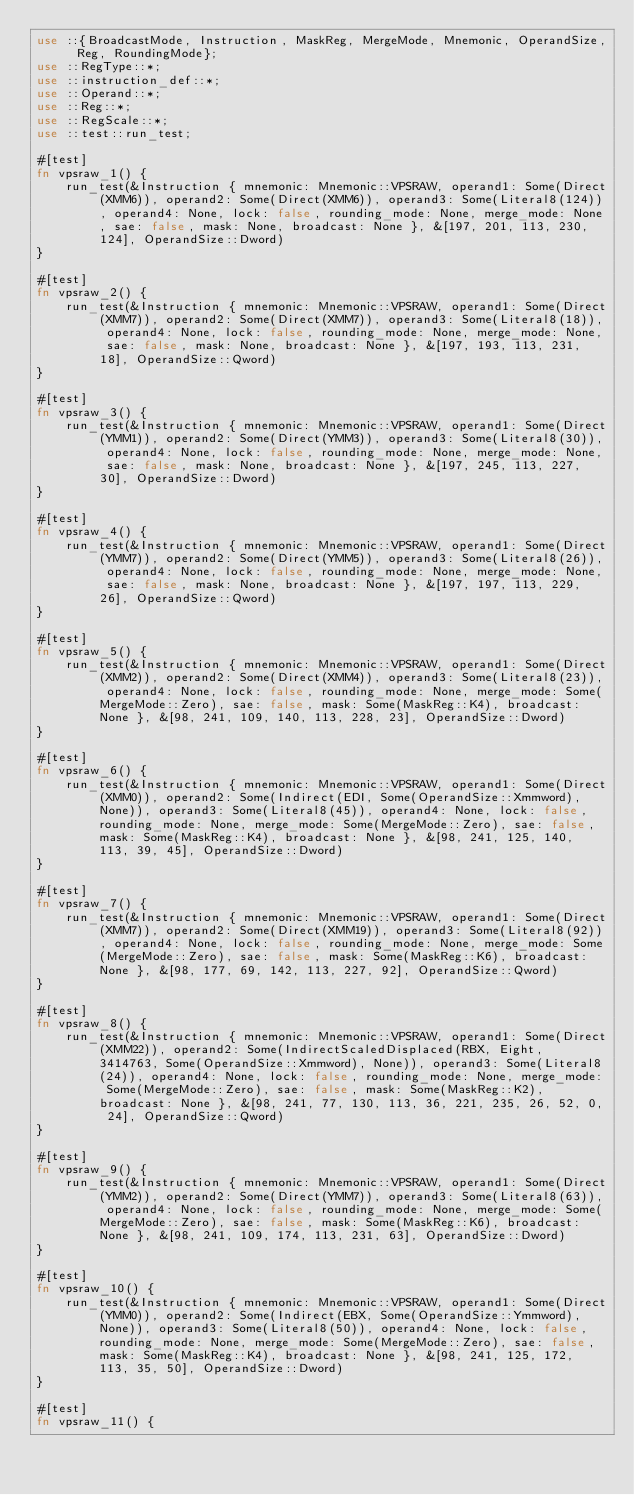<code> <loc_0><loc_0><loc_500><loc_500><_Rust_>use ::{BroadcastMode, Instruction, MaskReg, MergeMode, Mnemonic, OperandSize, Reg, RoundingMode};
use ::RegType::*;
use ::instruction_def::*;
use ::Operand::*;
use ::Reg::*;
use ::RegScale::*;
use ::test::run_test;

#[test]
fn vpsraw_1() {
    run_test(&Instruction { mnemonic: Mnemonic::VPSRAW, operand1: Some(Direct(XMM6)), operand2: Some(Direct(XMM6)), operand3: Some(Literal8(124)), operand4: None, lock: false, rounding_mode: None, merge_mode: None, sae: false, mask: None, broadcast: None }, &[197, 201, 113, 230, 124], OperandSize::Dword)
}

#[test]
fn vpsraw_2() {
    run_test(&Instruction { mnemonic: Mnemonic::VPSRAW, operand1: Some(Direct(XMM7)), operand2: Some(Direct(XMM7)), operand3: Some(Literal8(18)), operand4: None, lock: false, rounding_mode: None, merge_mode: None, sae: false, mask: None, broadcast: None }, &[197, 193, 113, 231, 18], OperandSize::Qword)
}

#[test]
fn vpsraw_3() {
    run_test(&Instruction { mnemonic: Mnemonic::VPSRAW, operand1: Some(Direct(YMM1)), operand2: Some(Direct(YMM3)), operand3: Some(Literal8(30)), operand4: None, lock: false, rounding_mode: None, merge_mode: None, sae: false, mask: None, broadcast: None }, &[197, 245, 113, 227, 30], OperandSize::Dword)
}

#[test]
fn vpsraw_4() {
    run_test(&Instruction { mnemonic: Mnemonic::VPSRAW, operand1: Some(Direct(YMM7)), operand2: Some(Direct(YMM5)), operand3: Some(Literal8(26)), operand4: None, lock: false, rounding_mode: None, merge_mode: None, sae: false, mask: None, broadcast: None }, &[197, 197, 113, 229, 26], OperandSize::Qword)
}

#[test]
fn vpsraw_5() {
    run_test(&Instruction { mnemonic: Mnemonic::VPSRAW, operand1: Some(Direct(XMM2)), operand2: Some(Direct(XMM4)), operand3: Some(Literal8(23)), operand4: None, lock: false, rounding_mode: None, merge_mode: Some(MergeMode::Zero), sae: false, mask: Some(MaskReg::K4), broadcast: None }, &[98, 241, 109, 140, 113, 228, 23], OperandSize::Dword)
}

#[test]
fn vpsraw_6() {
    run_test(&Instruction { mnemonic: Mnemonic::VPSRAW, operand1: Some(Direct(XMM0)), operand2: Some(Indirect(EDI, Some(OperandSize::Xmmword), None)), operand3: Some(Literal8(45)), operand4: None, lock: false, rounding_mode: None, merge_mode: Some(MergeMode::Zero), sae: false, mask: Some(MaskReg::K4), broadcast: None }, &[98, 241, 125, 140, 113, 39, 45], OperandSize::Dword)
}

#[test]
fn vpsraw_7() {
    run_test(&Instruction { mnemonic: Mnemonic::VPSRAW, operand1: Some(Direct(XMM7)), operand2: Some(Direct(XMM19)), operand3: Some(Literal8(92)), operand4: None, lock: false, rounding_mode: None, merge_mode: Some(MergeMode::Zero), sae: false, mask: Some(MaskReg::K6), broadcast: None }, &[98, 177, 69, 142, 113, 227, 92], OperandSize::Qword)
}

#[test]
fn vpsraw_8() {
    run_test(&Instruction { mnemonic: Mnemonic::VPSRAW, operand1: Some(Direct(XMM22)), operand2: Some(IndirectScaledDisplaced(RBX, Eight, 3414763, Some(OperandSize::Xmmword), None)), operand3: Some(Literal8(24)), operand4: None, lock: false, rounding_mode: None, merge_mode: Some(MergeMode::Zero), sae: false, mask: Some(MaskReg::K2), broadcast: None }, &[98, 241, 77, 130, 113, 36, 221, 235, 26, 52, 0, 24], OperandSize::Qword)
}

#[test]
fn vpsraw_9() {
    run_test(&Instruction { mnemonic: Mnemonic::VPSRAW, operand1: Some(Direct(YMM2)), operand2: Some(Direct(YMM7)), operand3: Some(Literal8(63)), operand4: None, lock: false, rounding_mode: None, merge_mode: Some(MergeMode::Zero), sae: false, mask: Some(MaskReg::K6), broadcast: None }, &[98, 241, 109, 174, 113, 231, 63], OperandSize::Dword)
}

#[test]
fn vpsraw_10() {
    run_test(&Instruction { mnemonic: Mnemonic::VPSRAW, operand1: Some(Direct(YMM0)), operand2: Some(Indirect(EBX, Some(OperandSize::Ymmword), None)), operand3: Some(Literal8(50)), operand4: None, lock: false, rounding_mode: None, merge_mode: Some(MergeMode::Zero), sae: false, mask: Some(MaskReg::K4), broadcast: None }, &[98, 241, 125, 172, 113, 35, 50], OperandSize::Dword)
}

#[test]
fn vpsraw_11() {</code> 